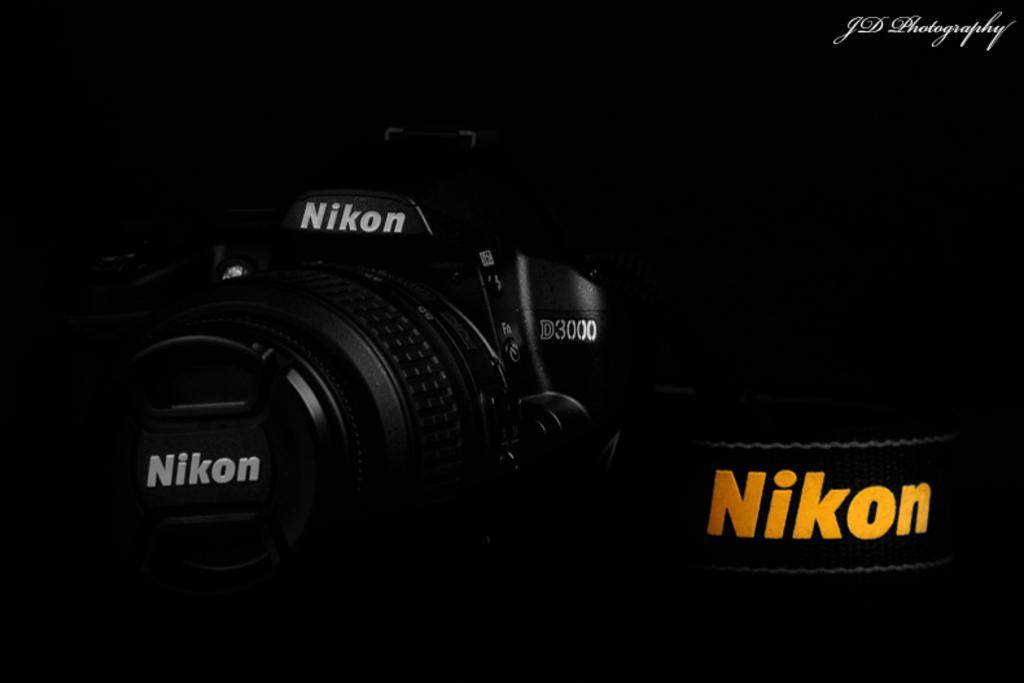What type of camera is visible in the image? There is a Nikon camera in the image. What color is the camera? The camera is black in color. How would you describe the background of the image? The background of the image appears dark. Can you identify any additional features on the image? Yes, there is a watermark in the top right side of the image. What type of pipe is being used by the mother in the image? There is no mother or pipe present in the image; it features a Nikon camera with a dark background and a watermark. 